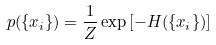<formula> <loc_0><loc_0><loc_500><loc_500>p ( \{ x _ { i } \} ) = \frac { 1 } { Z } \exp \left [ - H ( \{ x _ { i } \} ) \right ]</formula> 